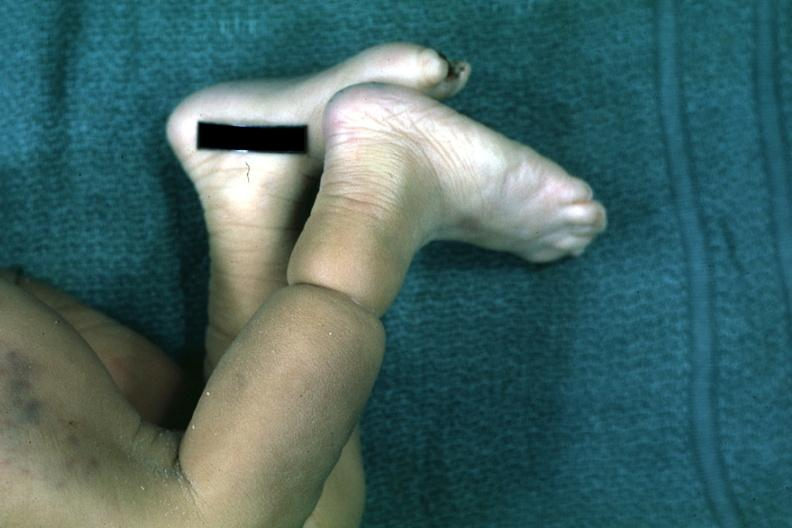what are present?
Answer the question using a single word or phrase. Extremities 